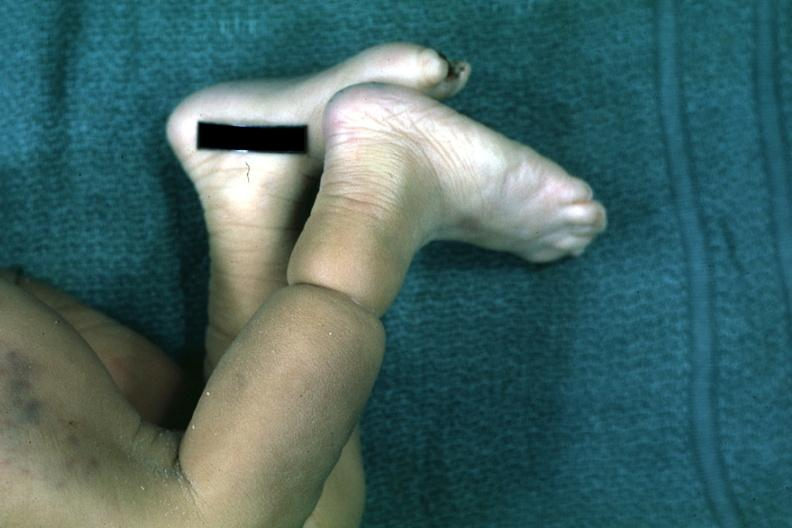what are present?
Answer the question using a single word or phrase. Extremities 